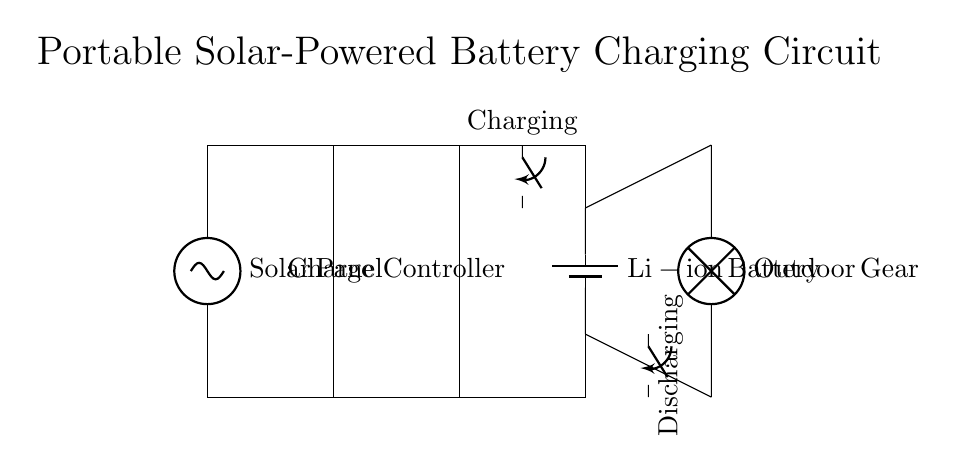What is the main component that collects solar energy? The main component that collects solar energy is the solar panel, which converts sunlight into electrical energy.
Answer: Solar panel What type of battery is used in this circuit? The battery used in this circuit is a lithium-ion battery, which is known for its efficiency in storing energy.
Answer: Li-ion battery How many switches are present in the circuit? There are two switches in the circuit, one for charging and another for discharging the battery to the load.
Answer: Two What does the charge controller do in this circuit? The charge controller regulates the voltage and current coming from the solar panel to the battery, protecting the battery from overcharging.
Answer: Regulates charging What is the load represented in the circuit? The load in the circuit represents the device or equipment powered by the battery, specifically outdoor gear in this scenario.
Answer: Outdoor gear What happens when the charging switch is open? When the charging switch is open, the solar panel cannot send power to the battery, and thus, no charging occurs.
Answer: No charging occurs What is the direction of current flow when discharging? The current flows from the battery to the outdoor gear when discharging, as indicated by the discharging switch position and connections.
Answer: Battery to load 